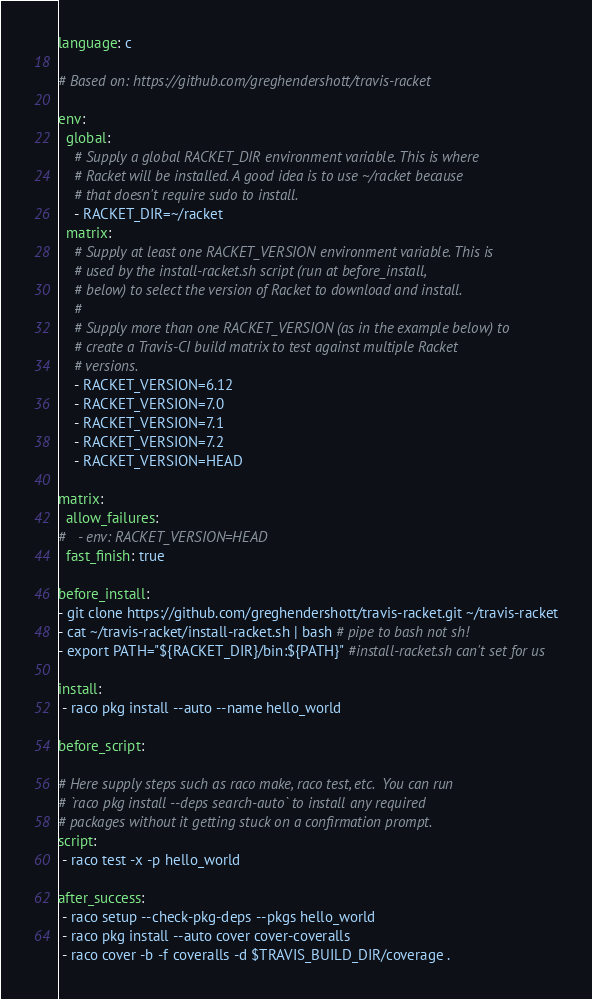<code> <loc_0><loc_0><loc_500><loc_500><_YAML_>language: c

# Based on: https://github.com/greghendershott/travis-racket

env:
  global:
    # Supply a global RACKET_DIR environment variable. This is where
    # Racket will be installed. A good idea is to use ~/racket because
    # that doesn't require sudo to install.
    - RACKET_DIR=~/racket
  matrix:
    # Supply at least one RACKET_VERSION environment variable. This is
    # used by the install-racket.sh script (run at before_install,
    # below) to select the version of Racket to download and install.
    #
    # Supply more than one RACKET_VERSION (as in the example below) to
    # create a Travis-CI build matrix to test against multiple Racket
    # versions.
    - RACKET_VERSION=6.12
    - RACKET_VERSION=7.0
    - RACKET_VERSION=7.1
    - RACKET_VERSION=7.2
    - RACKET_VERSION=HEAD

matrix:
  allow_failures:
#   - env: RACKET_VERSION=HEAD
  fast_finish: true

before_install:
- git clone https://github.com/greghendershott/travis-racket.git ~/travis-racket
- cat ~/travis-racket/install-racket.sh | bash # pipe to bash not sh!
- export PATH="${RACKET_DIR}/bin:${PATH}" #install-racket.sh can't set for us

install:
 - raco pkg install --auto --name hello_world

before_script:

# Here supply steps such as raco make, raco test, etc.  You can run
# `raco pkg install --deps search-auto` to install any required
# packages without it getting stuck on a confirmation prompt.
script:
 - raco test -x -p hello_world

after_success:
 - raco setup --check-pkg-deps --pkgs hello_world
 - raco pkg install --auto cover cover-coveralls
 - raco cover -b -f coveralls -d $TRAVIS_BUILD_DIR/coverage .
</code> 